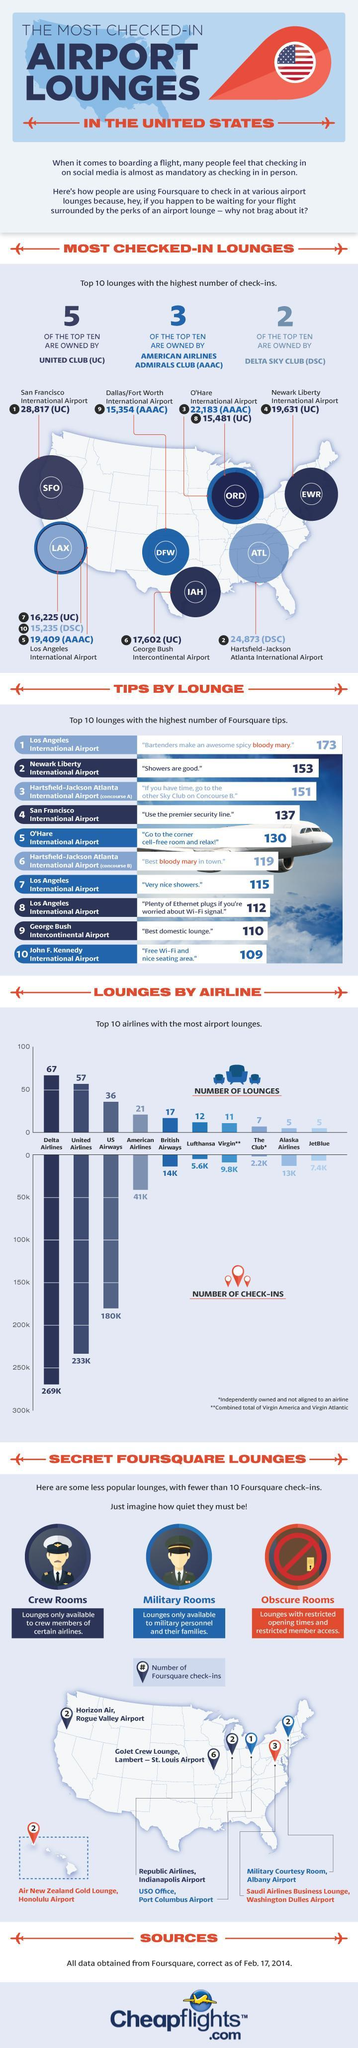What is the number of check-ins for both United Airlines and British Airways?
Answer the question with a short phrase. 247K How many lounges do both Alaska Airlines and JetBlue have? 10 Who owns the maximum number of top 10 most checked in lounges? UNITED CLUB (UC) Which airline has the most number of lounges? Delta Airlines 